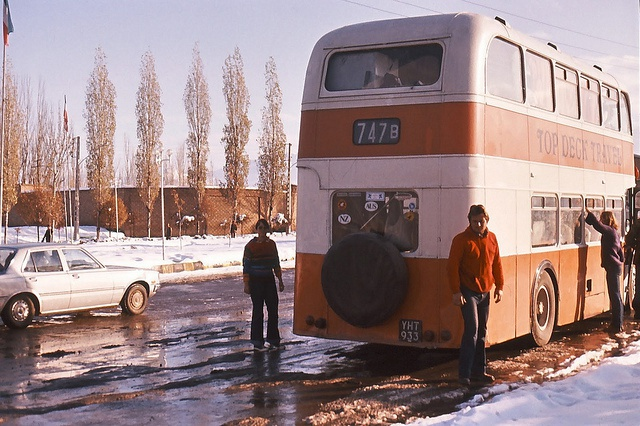Describe the objects in this image and their specific colors. I can see bus in lavender, lightgray, maroon, black, and tan tones, car in lavender, white, darkgray, black, and pink tones, people in lavender, maroon, black, red, and brown tones, people in lavender, black, maroon, gray, and white tones, and people in lavender, black, maroon, gray, and brown tones in this image. 